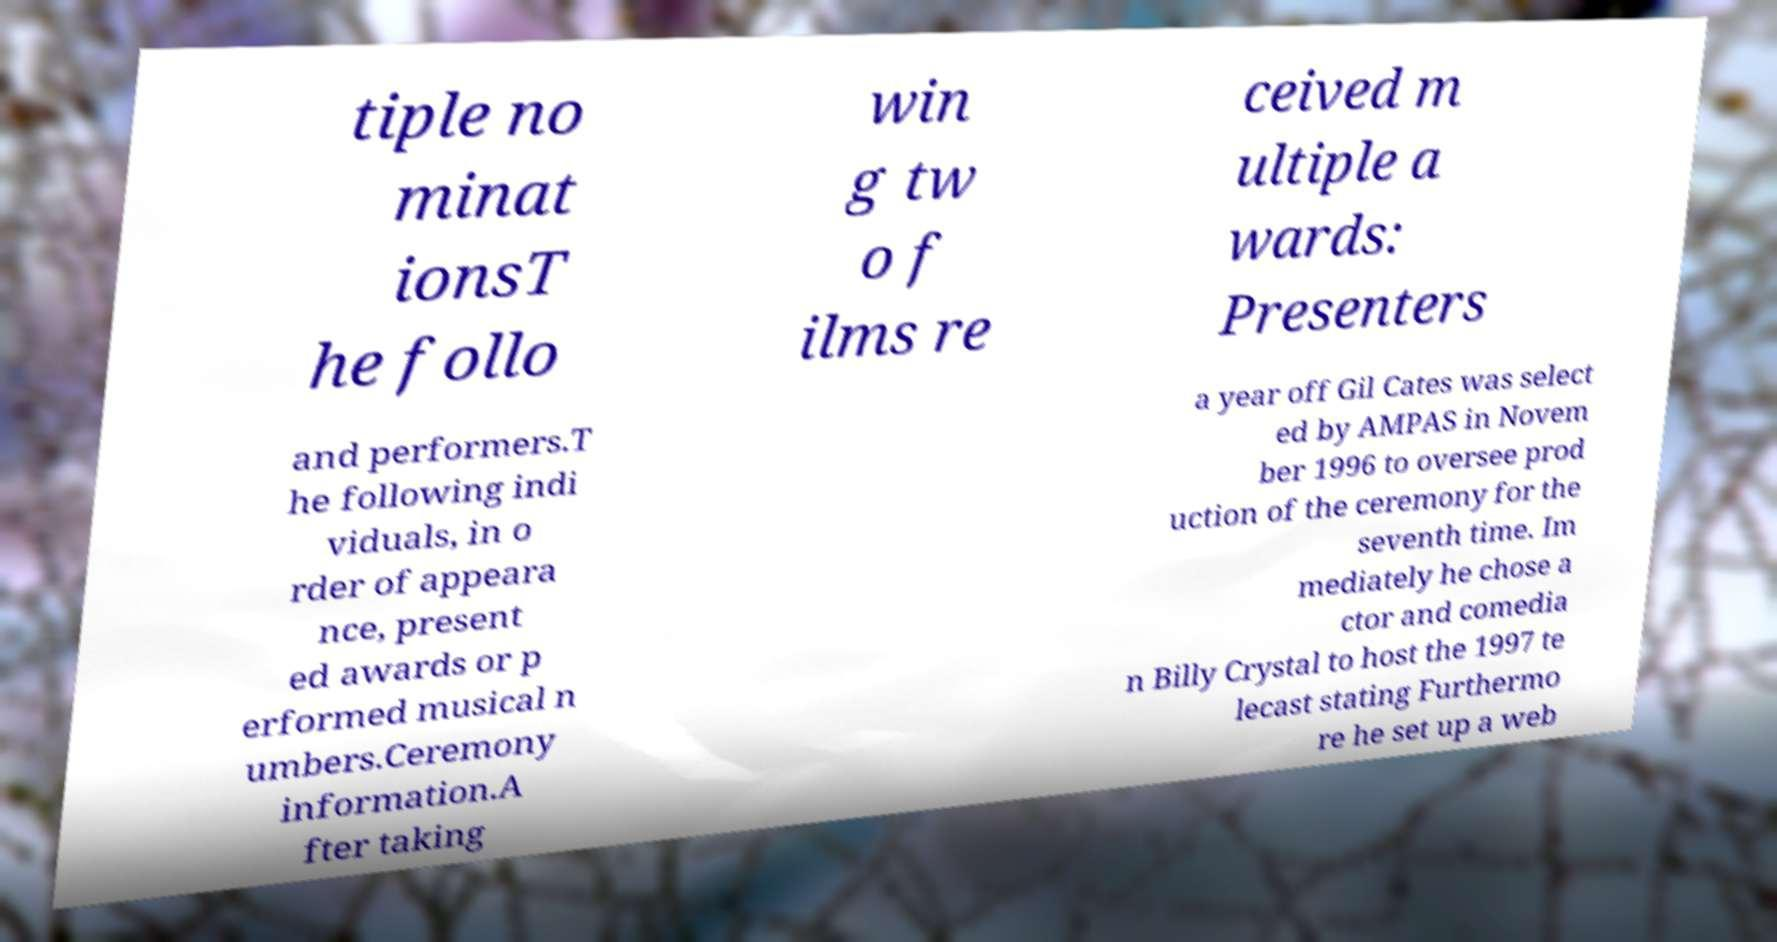There's text embedded in this image that I need extracted. Can you transcribe it verbatim? tiple no minat ionsT he follo win g tw o f ilms re ceived m ultiple a wards: Presenters and performers.T he following indi viduals, in o rder of appeara nce, present ed awards or p erformed musical n umbers.Ceremony information.A fter taking a year off Gil Cates was select ed by AMPAS in Novem ber 1996 to oversee prod uction of the ceremony for the seventh time. Im mediately he chose a ctor and comedia n Billy Crystal to host the 1997 te lecast stating Furthermo re he set up a web 